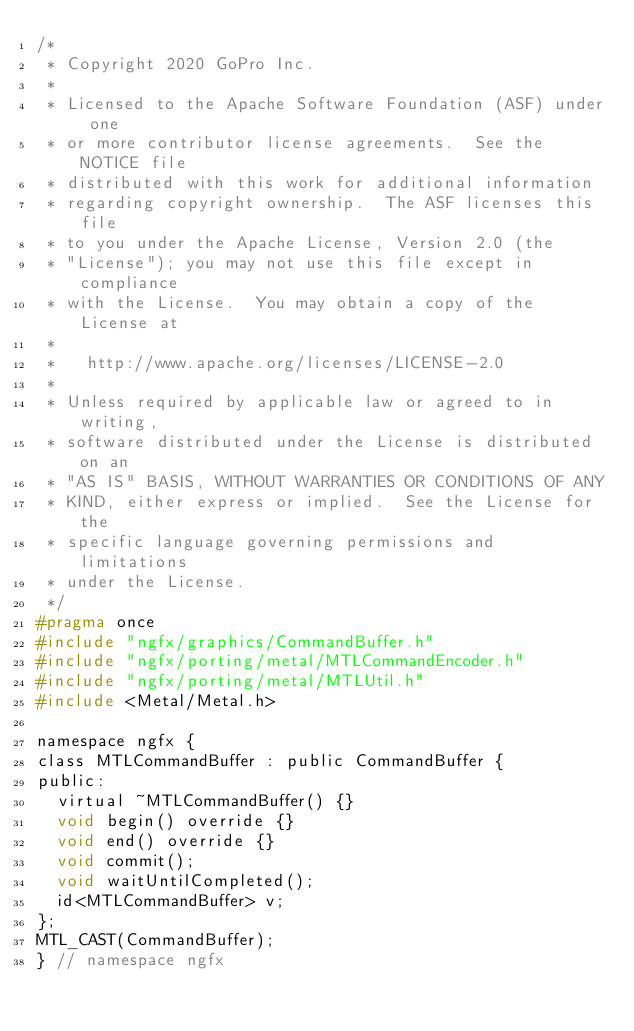Convert code to text. <code><loc_0><loc_0><loc_500><loc_500><_C_>/*
 * Copyright 2020 GoPro Inc.
 *
 * Licensed to the Apache Software Foundation (ASF) under one
 * or more contributor license agreements.  See the NOTICE file
 * distributed with this work for additional information
 * regarding copyright ownership.  The ASF licenses this file
 * to you under the Apache License, Version 2.0 (the
 * "License"); you may not use this file except in compliance
 * with the License.  You may obtain a copy of the License at
 *
 *   http://www.apache.org/licenses/LICENSE-2.0
 *
 * Unless required by applicable law or agreed to in writing,
 * software distributed under the License is distributed on an
 * "AS IS" BASIS, WITHOUT WARRANTIES OR CONDITIONS OF ANY
 * KIND, either express or implied.  See the License for the
 * specific language governing permissions and limitations
 * under the License.
 */
#pragma once
#include "ngfx/graphics/CommandBuffer.h"
#include "ngfx/porting/metal/MTLCommandEncoder.h"
#include "ngfx/porting/metal/MTLUtil.h"
#include <Metal/Metal.h>

namespace ngfx {
class MTLCommandBuffer : public CommandBuffer {
public:
  virtual ~MTLCommandBuffer() {}
  void begin() override {}
  void end() override {}
  void commit();
  void waitUntilCompleted();
  id<MTLCommandBuffer> v;
};
MTL_CAST(CommandBuffer);
} // namespace ngfx
</code> 